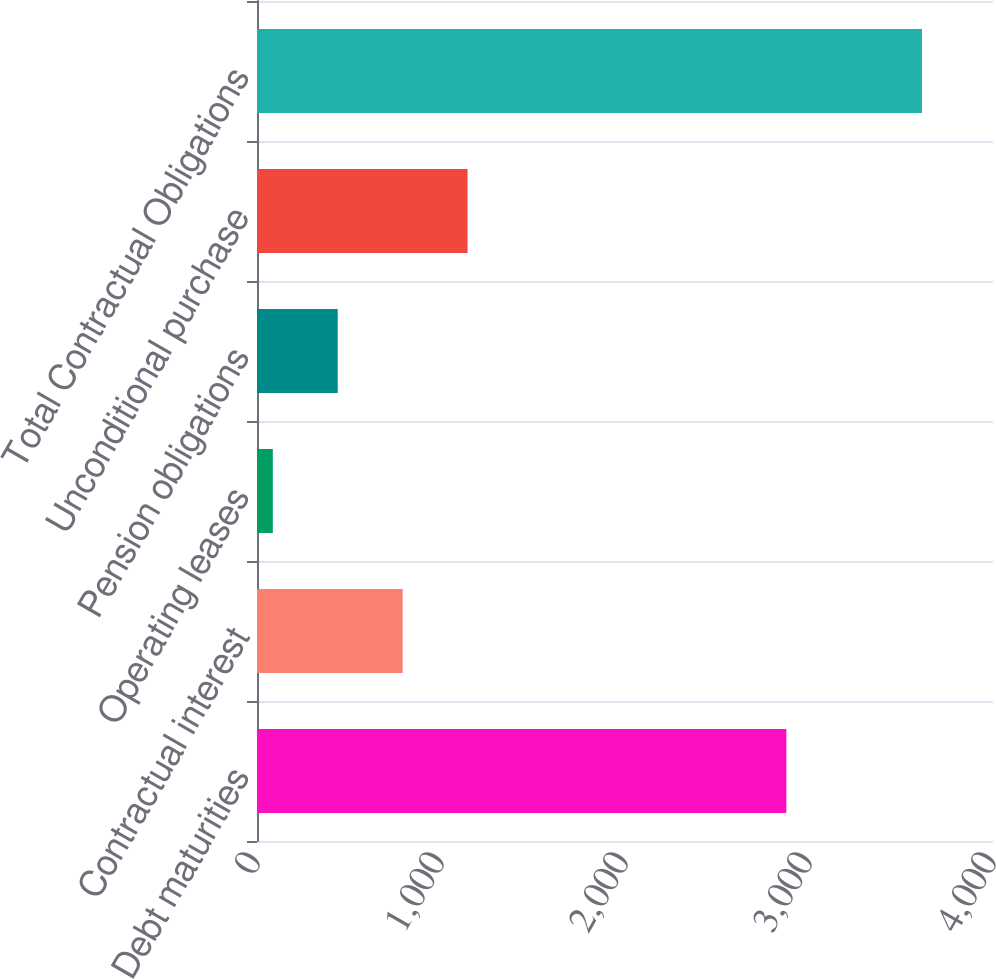<chart> <loc_0><loc_0><loc_500><loc_500><bar_chart><fcel>Debt maturities<fcel>Contractual interest<fcel>Operating leases<fcel>Pension obligations<fcel>Unconditional purchase<fcel>Total Contractual Obligations<nl><fcel>2877<fcel>791.6<fcel>86<fcel>438.8<fcel>1144.4<fcel>3614<nl></chart> 